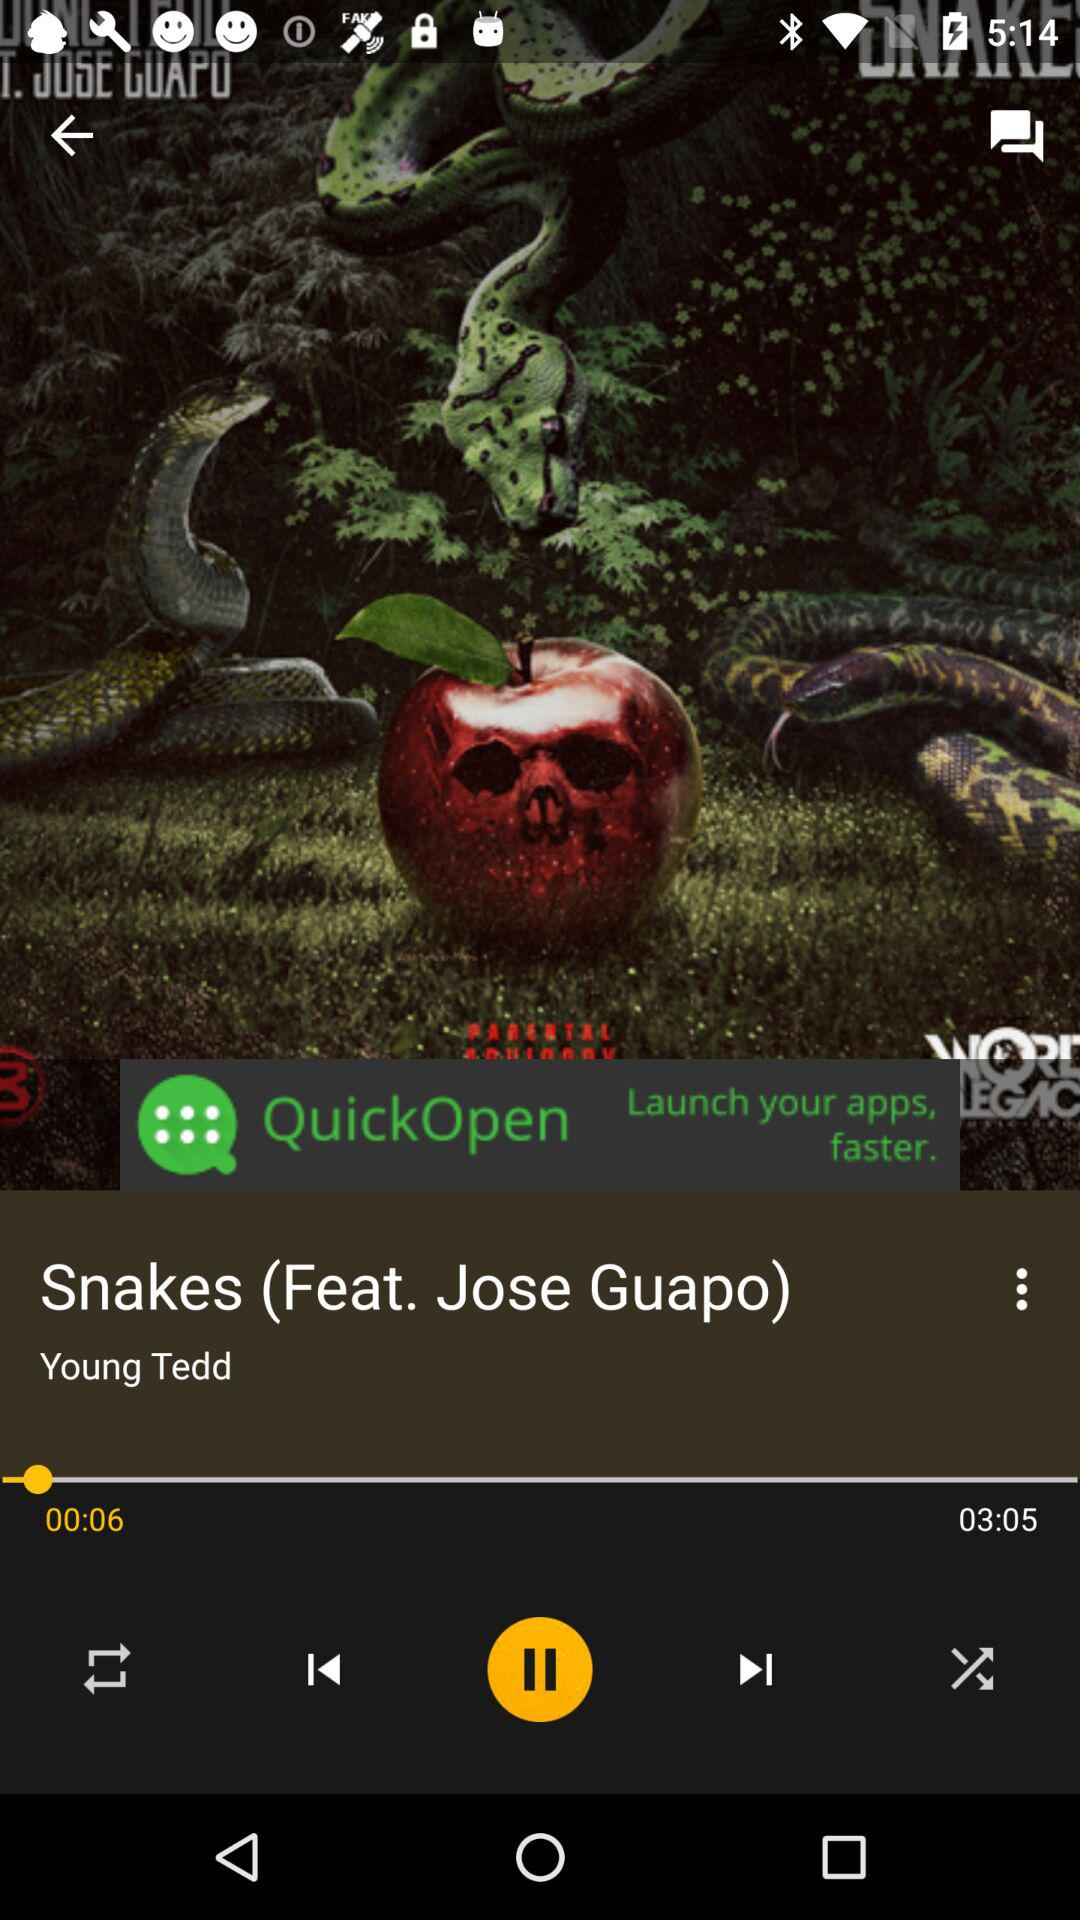What is the duration of the song? The duration is 3 minutes 5 seconds. 